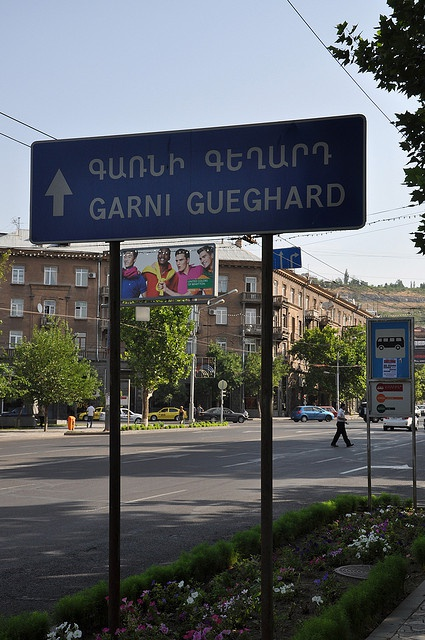Describe the objects in this image and their specific colors. I can see car in darkgray, black, gray, blue, and navy tones, car in darkgray, black, and gray tones, people in darkgray, black, and gray tones, car in darkgray, black, and olive tones, and car in darkgray, black, gray, and lightgray tones in this image. 